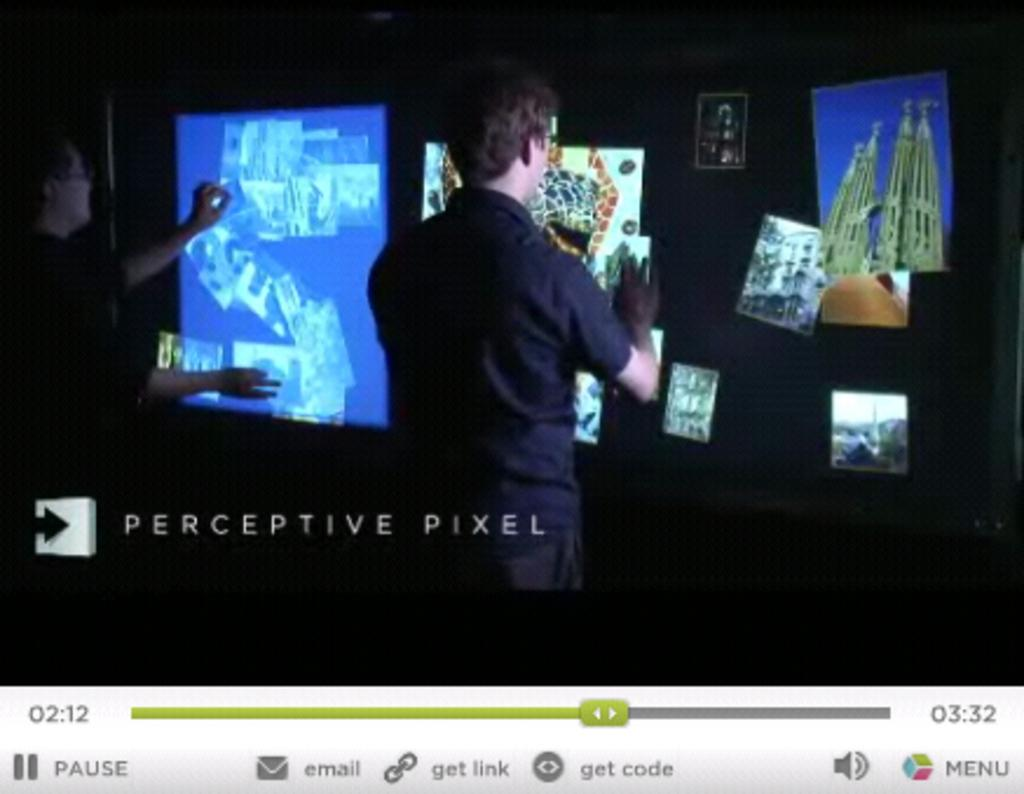<image>
Relay a brief, clear account of the picture shown. A Perceptive Pixel video at the 2 minute and 12 second mark. 